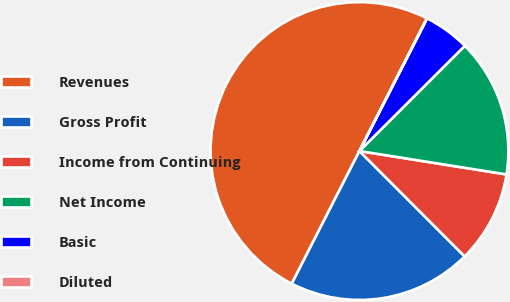Convert chart. <chart><loc_0><loc_0><loc_500><loc_500><pie_chart><fcel>Revenues<fcel>Gross Profit<fcel>Income from Continuing<fcel>Net Income<fcel>Basic<fcel>Diluted<nl><fcel>49.98%<fcel>20.0%<fcel>10.0%<fcel>15.0%<fcel>5.01%<fcel>0.01%<nl></chart> 